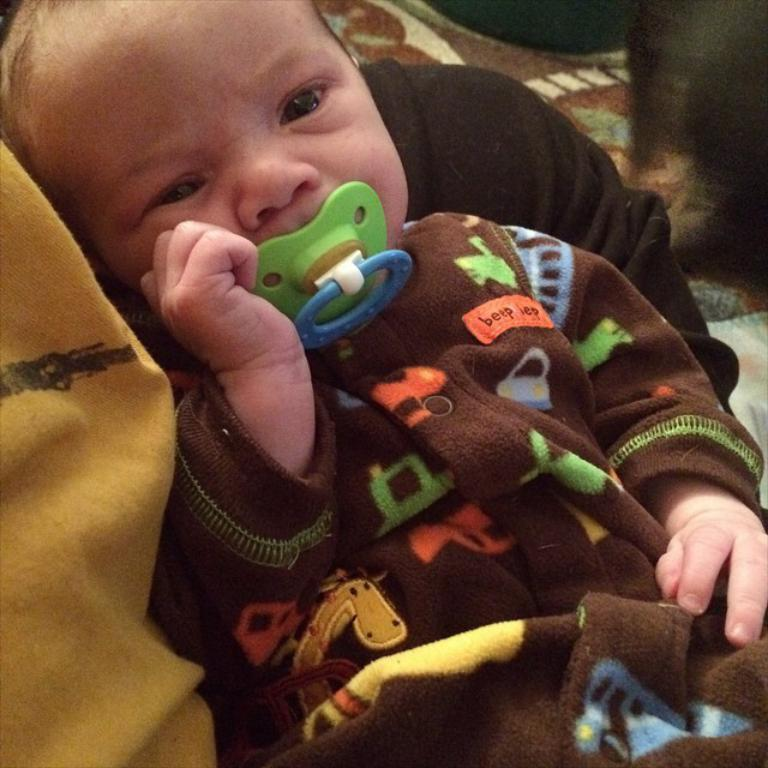What is the main subject of the image? There is a human in the image. What is the human doing in the image? The human is holding a baby. Can you describe the baby's action in the image? The baby has a nipple in its mouth. Where is the shelf located in the image? There is no shelf present in the image. What is the baby saying good-bye to in the image? The baby is not saying good-bye to anything in the image, as it is focused on sucking on a nipple. Who is the sister of the baby in the image? There is no mention of a sister in the image or the provided facts. 